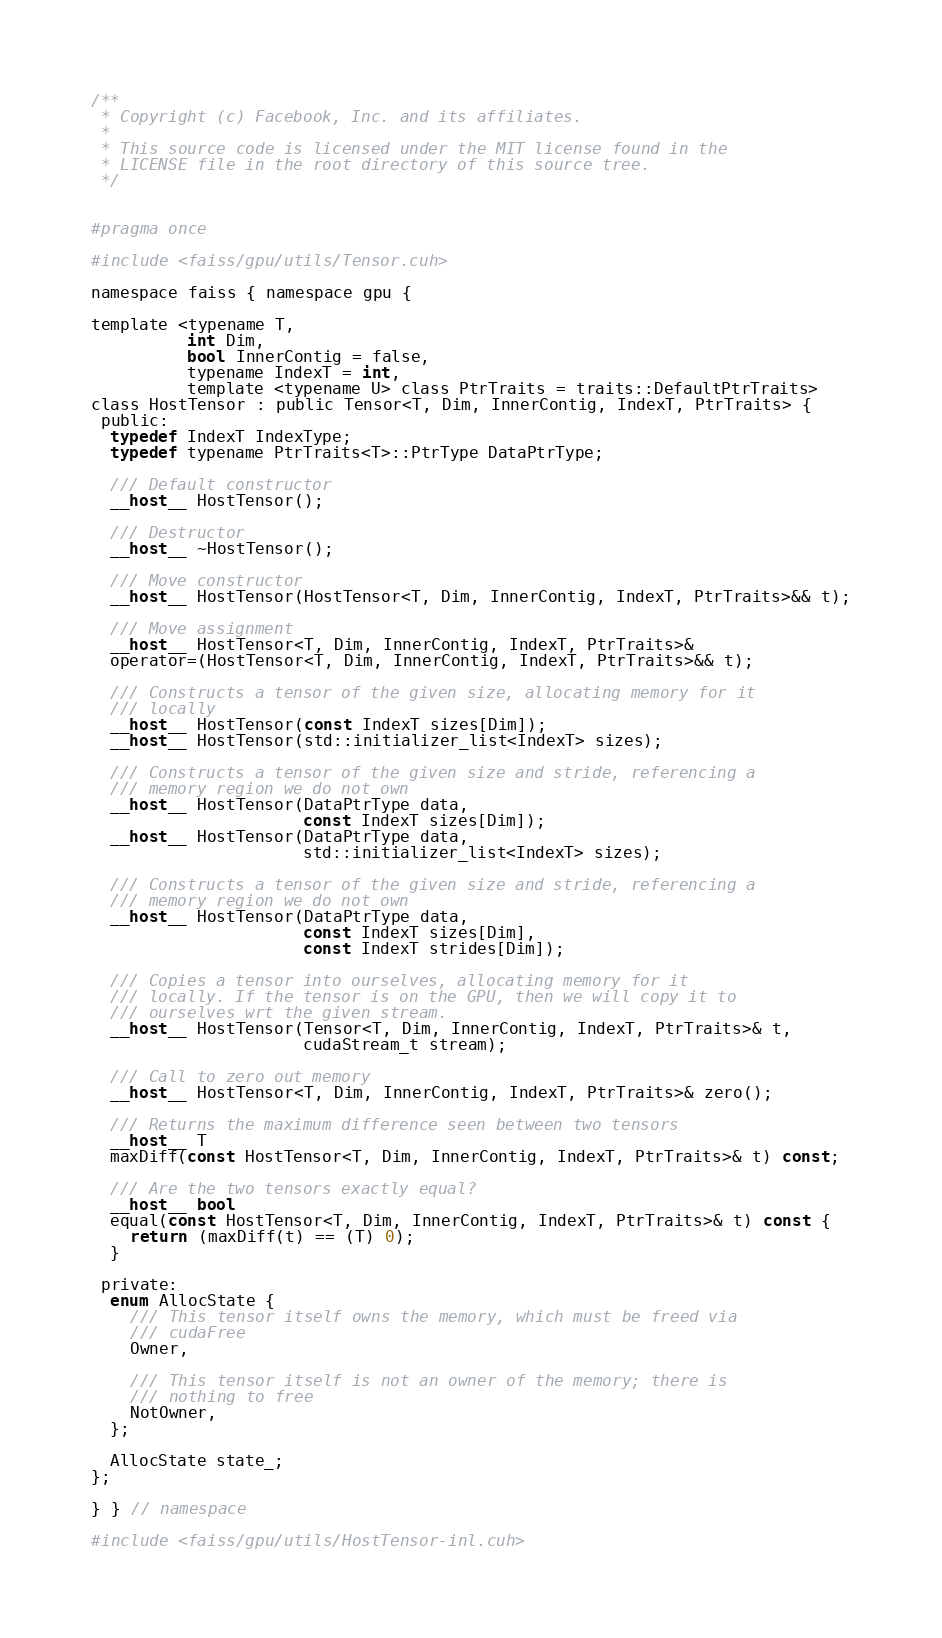<code> <loc_0><loc_0><loc_500><loc_500><_Cuda_>/**
 * Copyright (c) Facebook, Inc. and its affiliates.
 *
 * This source code is licensed under the MIT license found in the
 * LICENSE file in the root directory of this source tree.
 */


#pragma once

#include <faiss/gpu/utils/Tensor.cuh>

namespace faiss { namespace gpu {

template <typename T,
          int Dim,
          bool InnerContig = false,
          typename IndexT = int,
          template <typename U> class PtrTraits = traits::DefaultPtrTraits>
class HostTensor : public Tensor<T, Dim, InnerContig, IndexT, PtrTraits> {
 public:
  typedef IndexT IndexType;
  typedef typename PtrTraits<T>::PtrType DataPtrType;

  /// Default constructor
  __host__ HostTensor();

  /// Destructor
  __host__ ~HostTensor();

  /// Move constructor
  __host__ HostTensor(HostTensor<T, Dim, InnerContig, IndexT, PtrTraits>&& t);

  /// Move assignment
  __host__ HostTensor<T, Dim, InnerContig, IndexT, PtrTraits>&
  operator=(HostTensor<T, Dim, InnerContig, IndexT, PtrTraits>&& t);

  /// Constructs a tensor of the given size, allocating memory for it
  /// locally
  __host__ HostTensor(const IndexT sizes[Dim]);
  __host__ HostTensor(std::initializer_list<IndexT> sizes);

  /// Constructs a tensor of the given size and stride, referencing a
  /// memory region we do not own
  __host__ HostTensor(DataPtrType data,
                      const IndexT sizes[Dim]);
  __host__ HostTensor(DataPtrType data,
                      std::initializer_list<IndexT> sizes);

  /// Constructs a tensor of the given size and stride, referencing a
  /// memory region we do not own
  __host__ HostTensor(DataPtrType data,
                      const IndexT sizes[Dim],
                      const IndexT strides[Dim]);

  /// Copies a tensor into ourselves, allocating memory for it
  /// locally. If the tensor is on the GPU, then we will copy it to
  /// ourselves wrt the given stream.
  __host__ HostTensor(Tensor<T, Dim, InnerContig, IndexT, PtrTraits>& t,
                      cudaStream_t stream);

  /// Call to zero out memory
  __host__ HostTensor<T, Dim, InnerContig, IndexT, PtrTraits>& zero();

  /// Returns the maximum difference seen between two tensors
  __host__ T
  maxDiff(const HostTensor<T, Dim, InnerContig, IndexT, PtrTraits>& t) const;

  /// Are the two tensors exactly equal?
  __host__ bool
  equal(const HostTensor<T, Dim, InnerContig, IndexT, PtrTraits>& t) const {
    return (maxDiff(t) == (T) 0);
  }

 private:
  enum AllocState {
    /// This tensor itself owns the memory, which must be freed via
    /// cudaFree
    Owner,

    /// This tensor itself is not an owner of the memory; there is
    /// nothing to free
    NotOwner,
  };

  AllocState state_;
};

} } // namespace

#include <faiss/gpu/utils/HostTensor-inl.cuh>
</code> 